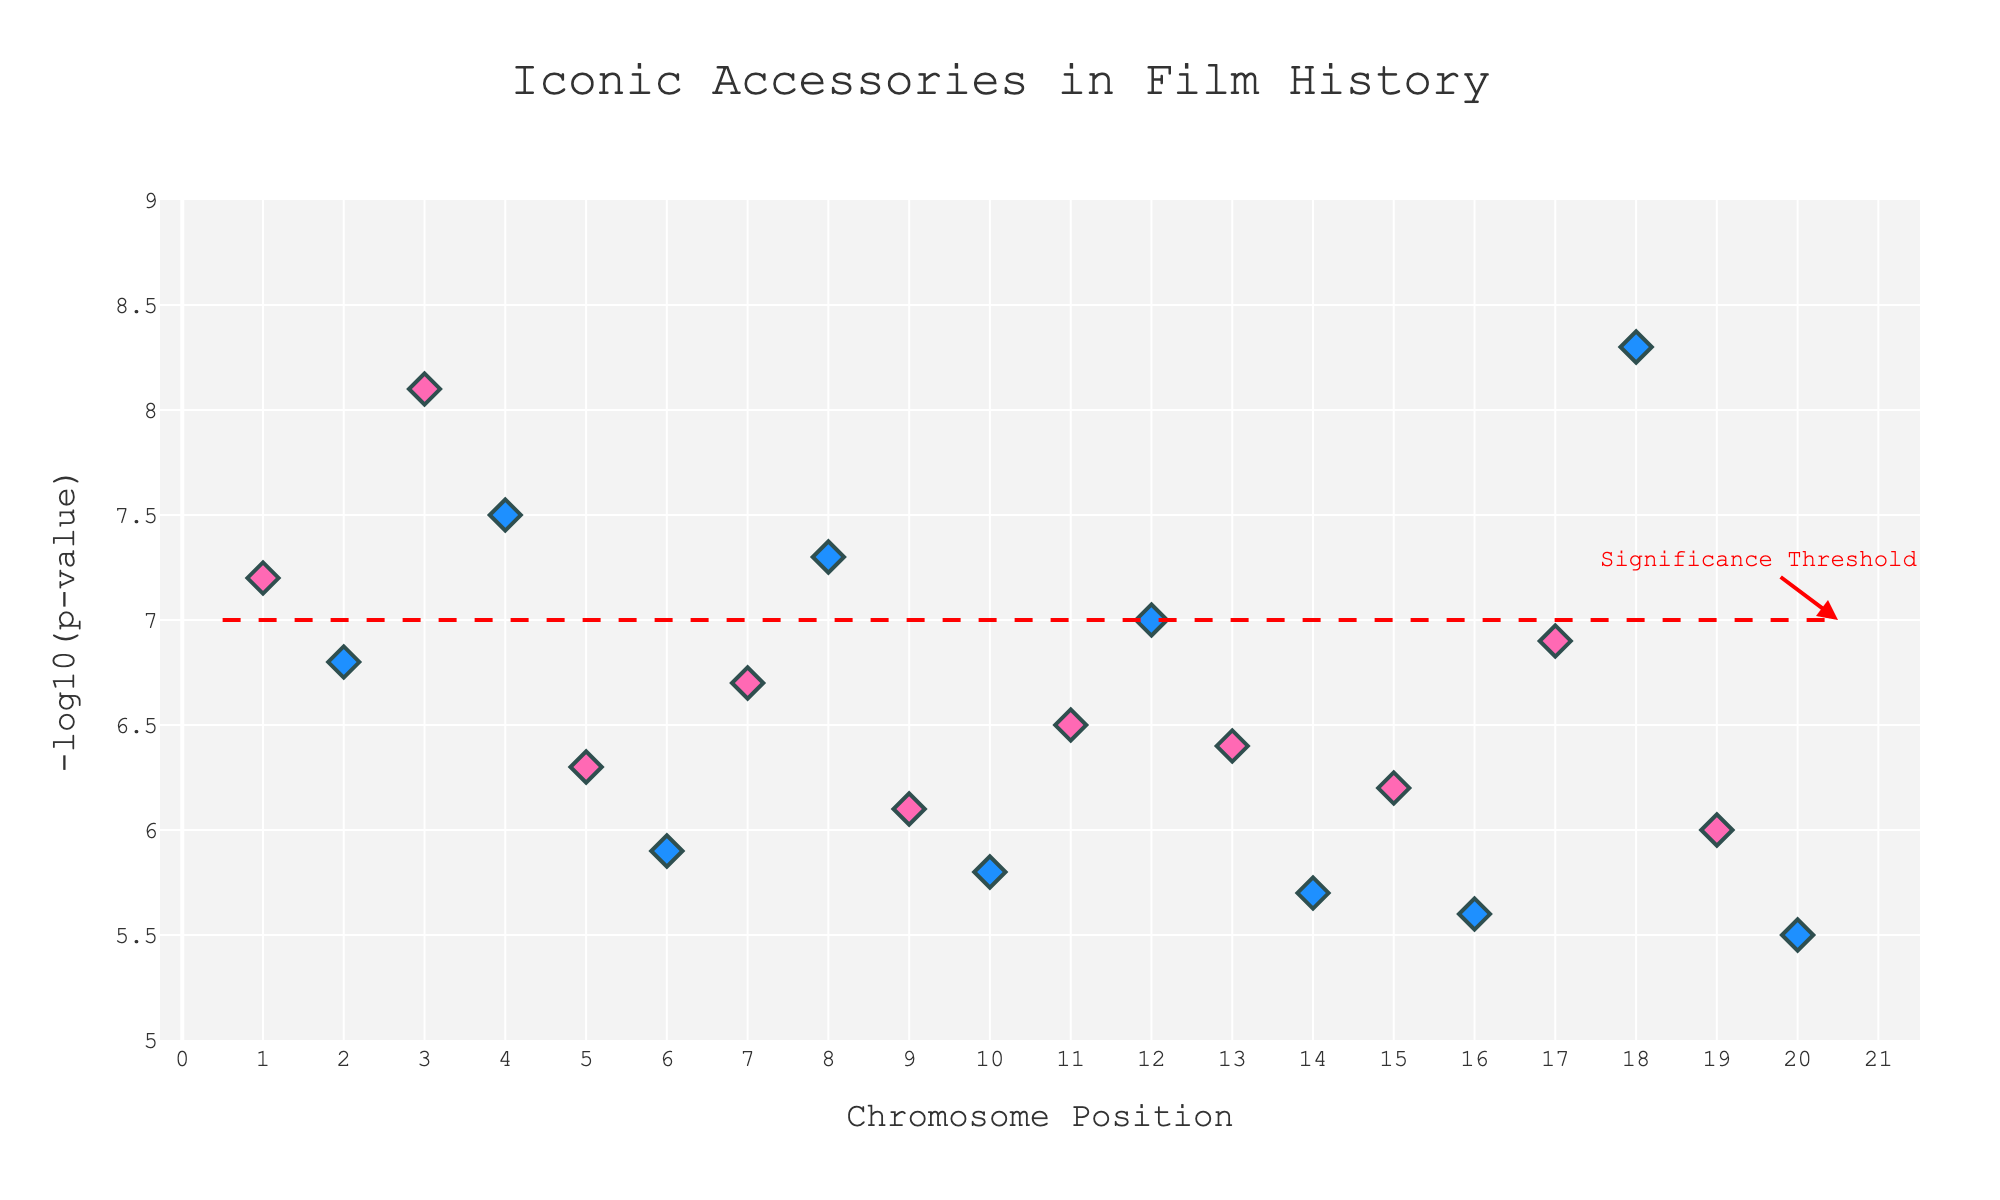What's the title of the plot? The title can be found at the top of the plot. It is typically displayed in a larger and bolder font compared to other text elements.
Answer: Iconic Accessories in Film History Which accessory is represented by the highest -log10(p-value)? Locate the data point with the highest y-axis value. Hover over the point to see the accessory name.
Answer: Judy Garland's Ruby Slippers What is the purpose of the horizontal red dashed line? The horizontal line often represents a significance threshold in Manhattan plots, which helps identify significant data points. The figure also has an annotation explaining this.
Answer: Significance Threshold How many accessories have a -log10(p-value) above the significance threshold? Count all data points that are above the red dashed line (y=7.0).
Answer: 7 Which accessory is associated with chromosome position 4? Find the data point on the x-axis at position 4 and hover over it to see the accessory name.
Answer: Elizabeth Taylor's Necklace How many accessories have a -log10(p-value) less than 6? Identify and count all data points that have a y-axis value less than 6.
Answer: 5 Are there more accessories with chromosome positions that are odd or even? List and count the accessories with odd-positioned chromosomes and even-positioned chromosomes on the x-axis, then compare.
Answer: Even Which two accessories have the closest -log10(p-values)? Compare the y-axis values of nearby points and identify the pair with the smallest difference.
Answer: Marilyn Monroe's Diamonds and Joan Crawford's Shoulder Pads Which accessory has a -log10(p-value) of exactly 6.1? Locate the data point on the y-axis at 6.1 and hover over it to see the accessory name.
Answer: Katharine Hepburn's Scarf If the significance threshold were raised to 7.5, how many accessories would meet the new threshold? Count all data points above the new threshold of y=7.5 as indicated by their -log10(p-value).
Answer: 3 